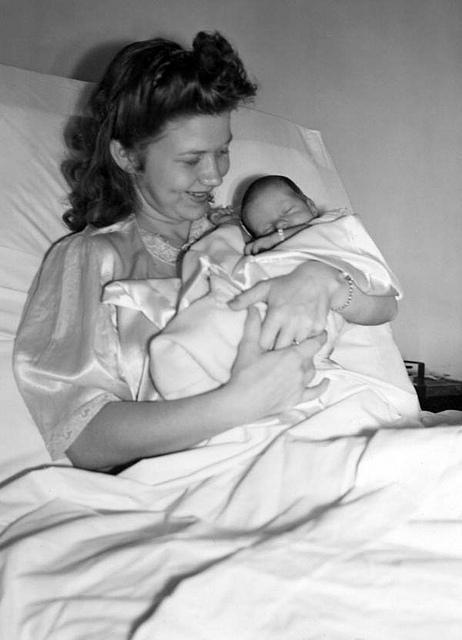How many beds are there?
Give a very brief answer. 2. 